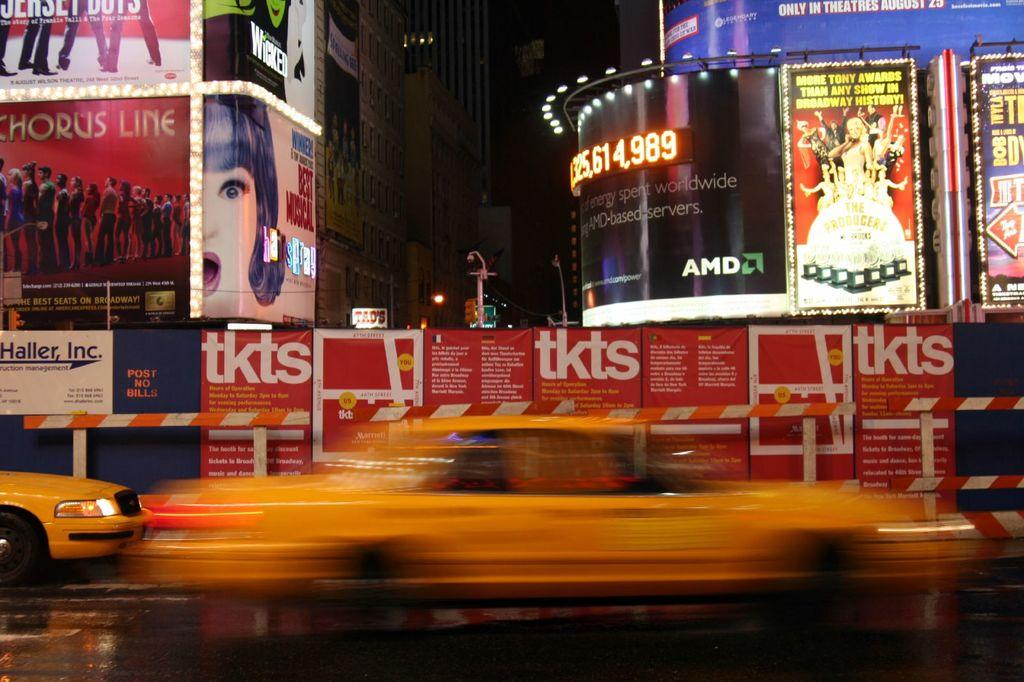<image>
Share a concise interpretation of the image provided. One of the Broadway shows being shown is a Chorus Line. 